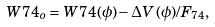Convert formula to latex. <formula><loc_0><loc_0><loc_500><loc_500>W 7 4 _ { o } = W 7 4 ( \phi ) - \Delta V ( \phi ) / F _ { 7 4 } ,</formula> 